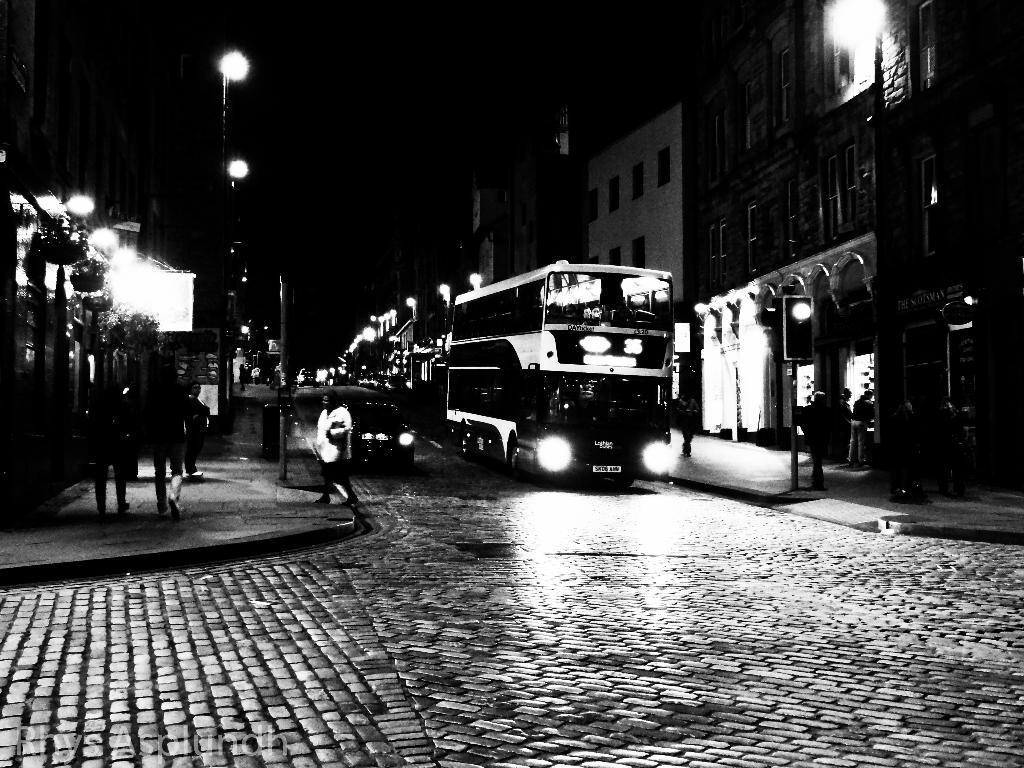Can you describe this image briefly? In this picture we can see vehicles on the road, some people are on the footpath, poles, lights, buildings, some objects and in the background it is dark. 